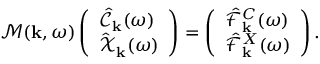<formula> <loc_0><loc_0><loc_500><loc_500>\mathcal { M } ( { k } , \omega ) \left ( \begin{array} { l } { \hat { \mathcal { C } } _ { k } ( \omega ) } \\ { \hat { \mathcal { X } } _ { k } ( \omega ) } \end{array} \right ) = \left ( \begin{array} { l } { \hat { \mathcal { F } } _ { k } ^ { C } ( \omega ) } \\ { \hat { \mathcal { F } } _ { k } ^ { X } ( \omega ) } \end{array} \right ) .</formula> 